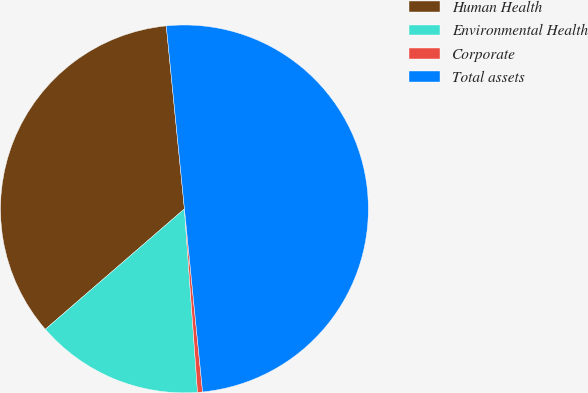<chart> <loc_0><loc_0><loc_500><loc_500><pie_chart><fcel>Human Health<fcel>Environmental Health<fcel>Corporate<fcel>Total assets<nl><fcel>34.78%<fcel>14.78%<fcel>0.44%<fcel>50.0%<nl></chart> 